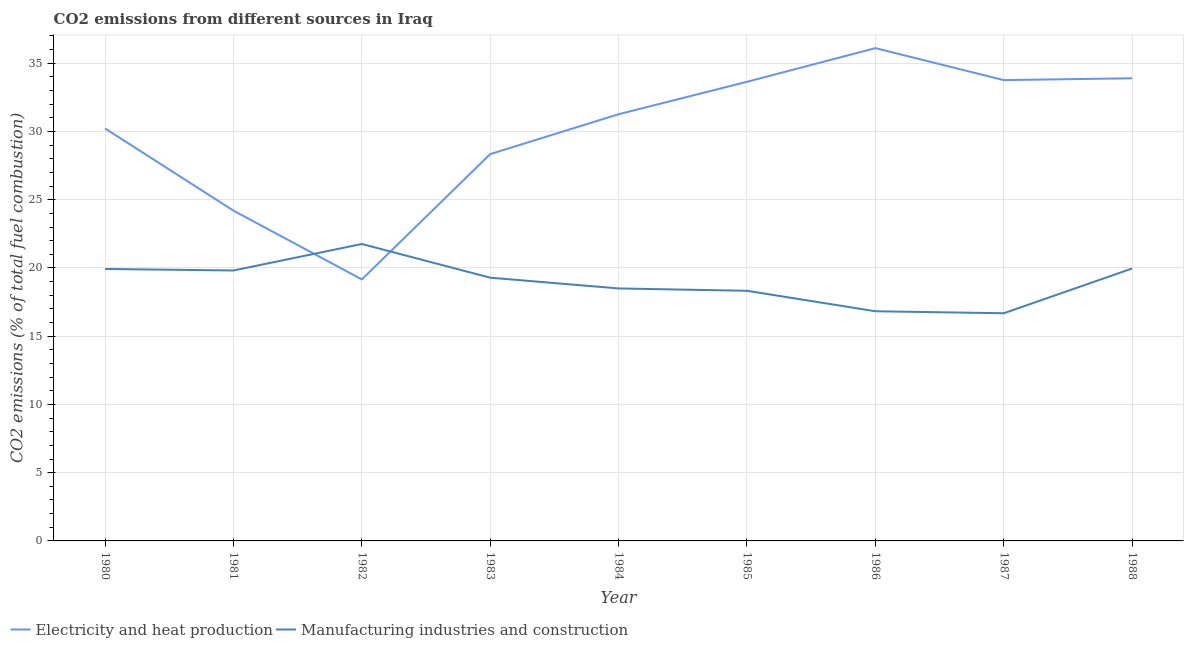What is the co2 emissions due to electricity and heat production in 1987?
Offer a very short reply. 33.77. Across all years, what is the maximum co2 emissions due to electricity and heat production?
Provide a succinct answer. 36.11. Across all years, what is the minimum co2 emissions due to electricity and heat production?
Your response must be concise. 19.16. What is the total co2 emissions due to manufacturing industries in the graph?
Your answer should be very brief. 171.08. What is the difference between the co2 emissions due to manufacturing industries in 1980 and that in 1986?
Provide a short and direct response. 3.1. What is the difference between the co2 emissions due to manufacturing industries in 1988 and the co2 emissions due to electricity and heat production in 1983?
Provide a succinct answer. -8.38. What is the average co2 emissions due to electricity and heat production per year?
Provide a short and direct response. 30.07. In the year 1988, what is the difference between the co2 emissions due to manufacturing industries and co2 emissions due to electricity and heat production?
Offer a very short reply. -13.94. In how many years, is the co2 emissions due to electricity and heat production greater than 2 %?
Provide a short and direct response. 9. What is the ratio of the co2 emissions due to manufacturing industries in 1981 to that in 1983?
Your answer should be compact. 1.03. Is the co2 emissions due to electricity and heat production in 1982 less than that in 1988?
Your answer should be compact. Yes. Is the difference between the co2 emissions due to electricity and heat production in 1980 and 1982 greater than the difference between the co2 emissions due to manufacturing industries in 1980 and 1982?
Provide a short and direct response. Yes. What is the difference between the highest and the second highest co2 emissions due to manufacturing industries?
Keep it short and to the point. 1.8. What is the difference between the highest and the lowest co2 emissions due to electricity and heat production?
Ensure brevity in your answer.  16.95. Does the co2 emissions due to electricity and heat production monotonically increase over the years?
Offer a terse response. No. Is the co2 emissions due to manufacturing industries strictly greater than the co2 emissions due to electricity and heat production over the years?
Keep it short and to the point. No. Is the co2 emissions due to electricity and heat production strictly less than the co2 emissions due to manufacturing industries over the years?
Keep it short and to the point. No. What is the difference between two consecutive major ticks on the Y-axis?
Make the answer very short. 5. Are the values on the major ticks of Y-axis written in scientific E-notation?
Your response must be concise. No. Does the graph contain any zero values?
Keep it short and to the point. No. Does the graph contain grids?
Your answer should be compact. Yes. How are the legend labels stacked?
Ensure brevity in your answer.  Horizontal. What is the title of the graph?
Your answer should be compact. CO2 emissions from different sources in Iraq. What is the label or title of the X-axis?
Keep it short and to the point. Year. What is the label or title of the Y-axis?
Your answer should be very brief. CO2 emissions (% of total fuel combustion). What is the CO2 emissions (% of total fuel combustion) in Electricity and heat production in 1980?
Offer a very short reply. 30.22. What is the CO2 emissions (% of total fuel combustion) in Manufacturing industries and construction in 1980?
Provide a succinct answer. 19.93. What is the CO2 emissions (% of total fuel combustion) in Electricity and heat production in 1981?
Your response must be concise. 24.2. What is the CO2 emissions (% of total fuel combustion) of Manufacturing industries and construction in 1981?
Give a very brief answer. 19.82. What is the CO2 emissions (% of total fuel combustion) of Electricity and heat production in 1982?
Your response must be concise. 19.16. What is the CO2 emissions (% of total fuel combustion) of Manufacturing industries and construction in 1982?
Offer a terse response. 21.76. What is the CO2 emissions (% of total fuel combustion) in Electricity and heat production in 1983?
Offer a very short reply. 28.34. What is the CO2 emissions (% of total fuel combustion) in Manufacturing industries and construction in 1983?
Ensure brevity in your answer.  19.29. What is the CO2 emissions (% of total fuel combustion) in Electricity and heat production in 1984?
Offer a very short reply. 31.26. What is the CO2 emissions (% of total fuel combustion) in Electricity and heat production in 1985?
Offer a terse response. 33.64. What is the CO2 emissions (% of total fuel combustion) in Manufacturing industries and construction in 1985?
Your response must be concise. 18.33. What is the CO2 emissions (% of total fuel combustion) of Electricity and heat production in 1986?
Ensure brevity in your answer.  36.11. What is the CO2 emissions (% of total fuel combustion) in Manufacturing industries and construction in 1986?
Provide a short and direct response. 16.83. What is the CO2 emissions (% of total fuel combustion) in Electricity and heat production in 1987?
Your answer should be very brief. 33.77. What is the CO2 emissions (% of total fuel combustion) in Manufacturing industries and construction in 1987?
Offer a very short reply. 16.68. What is the CO2 emissions (% of total fuel combustion) in Electricity and heat production in 1988?
Give a very brief answer. 33.9. What is the CO2 emissions (% of total fuel combustion) in Manufacturing industries and construction in 1988?
Keep it short and to the point. 19.96. Across all years, what is the maximum CO2 emissions (% of total fuel combustion) of Electricity and heat production?
Offer a very short reply. 36.11. Across all years, what is the maximum CO2 emissions (% of total fuel combustion) in Manufacturing industries and construction?
Make the answer very short. 21.76. Across all years, what is the minimum CO2 emissions (% of total fuel combustion) of Electricity and heat production?
Offer a terse response. 19.16. Across all years, what is the minimum CO2 emissions (% of total fuel combustion) in Manufacturing industries and construction?
Your response must be concise. 16.68. What is the total CO2 emissions (% of total fuel combustion) of Electricity and heat production in the graph?
Make the answer very short. 270.6. What is the total CO2 emissions (% of total fuel combustion) in Manufacturing industries and construction in the graph?
Provide a succinct answer. 171.08. What is the difference between the CO2 emissions (% of total fuel combustion) of Electricity and heat production in 1980 and that in 1981?
Your answer should be very brief. 6.02. What is the difference between the CO2 emissions (% of total fuel combustion) in Manufacturing industries and construction in 1980 and that in 1981?
Your answer should be very brief. 0.11. What is the difference between the CO2 emissions (% of total fuel combustion) in Electricity and heat production in 1980 and that in 1982?
Provide a succinct answer. 11.06. What is the difference between the CO2 emissions (% of total fuel combustion) of Manufacturing industries and construction in 1980 and that in 1982?
Provide a short and direct response. -1.83. What is the difference between the CO2 emissions (% of total fuel combustion) of Electricity and heat production in 1980 and that in 1983?
Ensure brevity in your answer.  1.88. What is the difference between the CO2 emissions (% of total fuel combustion) in Manufacturing industries and construction in 1980 and that in 1983?
Provide a short and direct response. 0.64. What is the difference between the CO2 emissions (% of total fuel combustion) of Electricity and heat production in 1980 and that in 1984?
Your answer should be very brief. -1.04. What is the difference between the CO2 emissions (% of total fuel combustion) of Manufacturing industries and construction in 1980 and that in 1984?
Your answer should be very brief. 1.43. What is the difference between the CO2 emissions (% of total fuel combustion) in Electricity and heat production in 1980 and that in 1985?
Keep it short and to the point. -3.42. What is the difference between the CO2 emissions (% of total fuel combustion) in Manufacturing industries and construction in 1980 and that in 1985?
Offer a very short reply. 1.6. What is the difference between the CO2 emissions (% of total fuel combustion) of Electricity and heat production in 1980 and that in 1986?
Your answer should be very brief. -5.88. What is the difference between the CO2 emissions (% of total fuel combustion) of Manufacturing industries and construction in 1980 and that in 1986?
Give a very brief answer. 3.1. What is the difference between the CO2 emissions (% of total fuel combustion) in Electricity and heat production in 1980 and that in 1987?
Provide a succinct answer. -3.54. What is the difference between the CO2 emissions (% of total fuel combustion) in Manufacturing industries and construction in 1980 and that in 1987?
Your answer should be very brief. 3.24. What is the difference between the CO2 emissions (% of total fuel combustion) in Electricity and heat production in 1980 and that in 1988?
Provide a short and direct response. -3.68. What is the difference between the CO2 emissions (% of total fuel combustion) of Manufacturing industries and construction in 1980 and that in 1988?
Make the answer very short. -0.04. What is the difference between the CO2 emissions (% of total fuel combustion) of Electricity and heat production in 1981 and that in 1982?
Provide a short and direct response. 5.04. What is the difference between the CO2 emissions (% of total fuel combustion) of Manufacturing industries and construction in 1981 and that in 1982?
Your answer should be very brief. -1.94. What is the difference between the CO2 emissions (% of total fuel combustion) in Electricity and heat production in 1981 and that in 1983?
Offer a very short reply. -4.14. What is the difference between the CO2 emissions (% of total fuel combustion) in Manufacturing industries and construction in 1981 and that in 1983?
Ensure brevity in your answer.  0.53. What is the difference between the CO2 emissions (% of total fuel combustion) in Electricity and heat production in 1981 and that in 1984?
Your answer should be very brief. -7.06. What is the difference between the CO2 emissions (% of total fuel combustion) in Manufacturing industries and construction in 1981 and that in 1984?
Your answer should be compact. 1.32. What is the difference between the CO2 emissions (% of total fuel combustion) of Electricity and heat production in 1981 and that in 1985?
Ensure brevity in your answer.  -9.44. What is the difference between the CO2 emissions (% of total fuel combustion) of Manufacturing industries and construction in 1981 and that in 1985?
Provide a short and direct response. 1.49. What is the difference between the CO2 emissions (% of total fuel combustion) of Electricity and heat production in 1981 and that in 1986?
Your answer should be very brief. -11.91. What is the difference between the CO2 emissions (% of total fuel combustion) in Manufacturing industries and construction in 1981 and that in 1986?
Keep it short and to the point. 2.99. What is the difference between the CO2 emissions (% of total fuel combustion) of Electricity and heat production in 1981 and that in 1987?
Provide a succinct answer. -9.56. What is the difference between the CO2 emissions (% of total fuel combustion) in Manufacturing industries and construction in 1981 and that in 1987?
Keep it short and to the point. 3.13. What is the difference between the CO2 emissions (% of total fuel combustion) in Electricity and heat production in 1981 and that in 1988?
Your answer should be very brief. -9.7. What is the difference between the CO2 emissions (% of total fuel combustion) of Manufacturing industries and construction in 1981 and that in 1988?
Your response must be concise. -0.15. What is the difference between the CO2 emissions (% of total fuel combustion) of Electricity and heat production in 1982 and that in 1983?
Offer a very short reply. -9.18. What is the difference between the CO2 emissions (% of total fuel combustion) in Manufacturing industries and construction in 1982 and that in 1983?
Keep it short and to the point. 2.47. What is the difference between the CO2 emissions (% of total fuel combustion) of Electricity and heat production in 1982 and that in 1984?
Your answer should be compact. -12.1. What is the difference between the CO2 emissions (% of total fuel combustion) of Manufacturing industries and construction in 1982 and that in 1984?
Provide a succinct answer. 3.26. What is the difference between the CO2 emissions (% of total fuel combustion) of Electricity and heat production in 1982 and that in 1985?
Your response must be concise. -14.48. What is the difference between the CO2 emissions (% of total fuel combustion) in Manufacturing industries and construction in 1982 and that in 1985?
Your response must be concise. 3.43. What is the difference between the CO2 emissions (% of total fuel combustion) in Electricity and heat production in 1982 and that in 1986?
Your answer should be very brief. -16.95. What is the difference between the CO2 emissions (% of total fuel combustion) of Manufacturing industries and construction in 1982 and that in 1986?
Give a very brief answer. 4.93. What is the difference between the CO2 emissions (% of total fuel combustion) in Electricity and heat production in 1982 and that in 1987?
Your answer should be compact. -14.6. What is the difference between the CO2 emissions (% of total fuel combustion) of Manufacturing industries and construction in 1982 and that in 1987?
Offer a very short reply. 5.07. What is the difference between the CO2 emissions (% of total fuel combustion) in Electricity and heat production in 1982 and that in 1988?
Offer a terse response. -14.74. What is the difference between the CO2 emissions (% of total fuel combustion) in Manufacturing industries and construction in 1982 and that in 1988?
Your answer should be compact. 1.8. What is the difference between the CO2 emissions (% of total fuel combustion) of Electricity and heat production in 1983 and that in 1984?
Make the answer very short. -2.92. What is the difference between the CO2 emissions (% of total fuel combustion) in Manufacturing industries and construction in 1983 and that in 1984?
Make the answer very short. 0.79. What is the difference between the CO2 emissions (% of total fuel combustion) of Electricity and heat production in 1983 and that in 1985?
Provide a succinct answer. -5.3. What is the difference between the CO2 emissions (% of total fuel combustion) in Manufacturing industries and construction in 1983 and that in 1985?
Ensure brevity in your answer.  0.96. What is the difference between the CO2 emissions (% of total fuel combustion) of Electricity and heat production in 1983 and that in 1986?
Make the answer very short. -7.76. What is the difference between the CO2 emissions (% of total fuel combustion) of Manufacturing industries and construction in 1983 and that in 1986?
Your answer should be very brief. 2.46. What is the difference between the CO2 emissions (% of total fuel combustion) of Electricity and heat production in 1983 and that in 1987?
Your response must be concise. -5.42. What is the difference between the CO2 emissions (% of total fuel combustion) in Manufacturing industries and construction in 1983 and that in 1987?
Give a very brief answer. 2.61. What is the difference between the CO2 emissions (% of total fuel combustion) of Electricity and heat production in 1983 and that in 1988?
Keep it short and to the point. -5.56. What is the difference between the CO2 emissions (% of total fuel combustion) in Manufacturing industries and construction in 1983 and that in 1988?
Your response must be concise. -0.67. What is the difference between the CO2 emissions (% of total fuel combustion) in Electricity and heat production in 1984 and that in 1985?
Make the answer very short. -2.38. What is the difference between the CO2 emissions (% of total fuel combustion) of Manufacturing industries and construction in 1984 and that in 1985?
Your answer should be compact. 0.17. What is the difference between the CO2 emissions (% of total fuel combustion) of Electricity and heat production in 1984 and that in 1986?
Provide a succinct answer. -4.84. What is the difference between the CO2 emissions (% of total fuel combustion) of Manufacturing industries and construction in 1984 and that in 1986?
Your answer should be compact. 1.67. What is the difference between the CO2 emissions (% of total fuel combustion) in Electricity and heat production in 1984 and that in 1987?
Your answer should be very brief. -2.5. What is the difference between the CO2 emissions (% of total fuel combustion) of Manufacturing industries and construction in 1984 and that in 1987?
Your answer should be compact. 1.82. What is the difference between the CO2 emissions (% of total fuel combustion) in Electricity and heat production in 1984 and that in 1988?
Offer a terse response. -2.63. What is the difference between the CO2 emissions (% of total fuel combustion) of Manufacturing industries and construction in 1984 and that in 1988?
Offer a very short reply. -1.46. What is the difference between the CO2 emissions (% of total fuel combustion) in Electricity and heat production in 1985 and that in 1986?
Give a very brief answer. -2.47. What is the difference between the CO2 emissions (% of total fuel combustion) in Manufacturing industries and construction in 1985 and that in 1986?
Provide a short and direct response. 1.5. What is the difference between the CO2 emissions (% of total fuel combustion) of Electricity and heat production in 1985 and that in 1987?
Ensure brevity in your answer.  -0.12. What is the difference between the CO2 emissions (% of total fuel combustion) in Manufacturing industries and construction in 1985 and that in 1987?
Keep it short and to the point. 1.65. What is the difference between the CO2 emissions (% of total fuel combustion) of Electricity and heat production in 1985 and that in 1988?
Your answer should be very brief. -0.26. What is the difference between the CO2 emissions (% of total fuel combustion) in Manufacturing industries and construction in 1985 and that in 1988?
Provide a short and direct response. -1.63. What is the difference between the CO2 emissions (% of total fuel combustion) in Electricity and heat production in 1986 and that in 1987?
Make the answer very short. 2.34. What is the difference between the CO2 emissions (% of total fuel combustion) of Manufacturing industries and construction in 1986 and that in 1987?
Your answer should be compact. 0.15. What is the difference between the CO2 emissions (% of total fuel combustion) of Electricity and heat production in 1986 and that in 1988?
Provide a short and direct response. 2.21. What is the difference between the CO2 emissions (% of total fuel combustion) in Manufacturing industries and construction in 1986 and that in 1988?
Your response must be concise. -3.13. What is the difference between the CO2 emissions (% of total fuel combustion) in Electricity and heat production in 1987 and that in 1988?
Your answer should be compact. -0.13. What is the difference between the CO2 emissions (% of total fuel combustion) in Manufacturing industries and construction in 1987 and that in 1988?
Make the answer very short. -3.28. What is the difference between the CO2 emissions (% of total fuel combustion) in Electricity and heat production in 1980 and the CO2 emissions (% of total fuel combustion) in Manufacturing industries and construction in 1981?
Ensure brevity in your answer.  10.41. What is the difference between the CO2 emissions (% of total fuel combustion) of Electricity and heat production in 1980 and the CO2 emissions (% of total fuel combustion) of Manufacturing industries and construction in 1982?
Ensure brevity in your answer.  8.47. What is the difference between the CO2 emissions (% of total fuel combustion) in Electricity and heat production in 1980 and the CO2 emissions (% of total fuel combustion) in Manufacturing industries and construction in 1983?
Provide a short and direct response. 10.93. What is the difference between the CO2 emissions (% of total fuel combustion) of Electricity and heat production in 1980 and the CO2 emissions (% of total fuel combustion) of Manufacturing industries and construction in 1984?
Keep it short and to the point. 11.72. What is the difference between the CO2 emissions (% of total fuel combustion) in Electricity and heat production in 1980 and the CO2 emissions (% of total fuel combustion) in Manufacturing industries and construction in 1985?
Your answer should be compact. 11.89. What is the difference between the CO2 emissions (% of total fuel combustion) in Electricity and heat production in 1980 and the CO2 emissions (% of total fuel combustion) in Manufacturing industries and construction in 1986?
Your answer should be compact. 13.39. What is the difference between the CO2 emissions (% of total fuel combustion) of Electricity and heat production in 1980 and the CO2 emissions (% of total fuel combustion) of Manufacturing industries and construction in 1987?
Offer a terse response. 13.54. What is the difference between the CO2 emissions (% of total fuel combustion) of Electricity and heat production in 1980 and the CO2 emissions (% of total fuel combustion) of Manufacturing industries and construction in 1988?
Your answer should be very brief. 10.26. What is the difference between the CO2 emissions (% of total fuel combustion) of Electricity and heat production in 1981 and the CO2 emissions (% of total fuel combustion) of Manufacturing industries and construction in 1982?
Offer a terse response. 2.45. What is the difference between the CO2 emissions (% of total fuel combustion) in Electricity and heat production in 1981 and the CO2 emissions (% of total fuel combustion) in Manufacturing industries and construction in 1983?
Offer a very short reply. 4.91. What is the difference between the CO2 emissions (% of total fuel combustion) of Electricity and heat production in 1981 and the CO2 emissions (% of total fuel combustion) of Manufacturing industries and construction in 1984?
Ensure brevity in your answer.  5.7. What is the difference between the CO2 emissions (% of total fuel combustion) in Electricity and heat production in 1981 and the CO2 emissions (% of total fuel combustion) in Manufacturing industries and construction in 1985?
Offer a very short reply. 5.87. What is the difference between the CO2 emissions (% of total fuel combustion) of Electricity and heat production in 1981 and the CO2 emissions (% of total fuel combustion) of Manufacturing industries and construction in 1986?
Give a very brief answer. 7.37. What is the difference between the CO2 emissions (% of total fuel combustion) of Electricity and heat production in 1981 and the CO2 emissions (% of total fuel combustion) of Manufacturing industries and construction in 1987?
Your response must be concise. 7.52. What is the difference between the CO2 emissions (% of total fuel combustion) of Electricity and heat production in 1981 and the CO2 emissions (% of total fuel combustion) of Manufacturing industries and construction in 1988?
Your answer should be very brief. 4.24. What is the difference between the CO2 emissions (% of total fuel combustion) of Electricity and heat production in 1982 and the CO2 emissions (% of total fuel combustion) of Manufacturing industries and construction in 1983?
Give a very brief answer. -0.13. What is the difference between the CO2 emissions (% of total fuel combustion) in Electricity and heat production in 1982 and the CO2 emissions (% of total fuel combustion) in Manufacturing industries and construction in 1984?
Your response must be concise. 0.66. What is the difference between the CO2 emissions (% of total fuel combustion) in Electricity and heat production in 1982 and the CO2 emissions (% of total fuel combustion) in Manufacturing industries and construction in 1985?
Your answer should be very brief. 0.83. What is the difference between the CO2 emissions (% of total fuel combustion) of Electricity and heat production in 1982 and the CO2 emissions (% of total fuel combustion) of Manufacturing industries and construction in 1986?
Provide a short and direct response. 2.33. What is the difference between the CO2 emissions (% of total fuel combustion) of Electricity and heat production in 1982 and the CO2 emissions (% of total fuel combustion) of Manufacturing industries and construction in 1987?
Keep it short and to the point. 2.48. What is the difference between the CO2 emissions (% of total fuel combustion) of Electricity and heat production in 1983 and the CO2 emissions (% of total fuel combustion) of Manufacturing industries and construction in 1984?
Offer a very short reply. 9.84. What is the difference between the CO2 emissions (% of total fuel combustion) of Electricity and heat production in 1983 and the CO2 emissions (% of total fuel combustion) of Manufacturing industries and construction in 1985?
Make the answer very short. 10.02. What is the difference between the CO2 emissions (% of total fuel combustion) of Electricity and heat production in 1983 and the CO2 emissions (% of total fuel combustion) of Manufacturing industries and construction in 1986?
Make the answer very short. 11.51. What is the difference between the CO2 emissions (% of total fuel combustion) of Electricity and heat production in 1983 and the CO2 emissions (% of total fuel combustion) of Manufacturing industries and construction in 1987?
Provide a succinct answer. 11.66. What is the difference between the CO2 emissions (% of total fuel combustion) of Electricity and heat production in 1983 and the CO2 emissions (% of total fuel combustion) of Manufacturing industries and construction in 1988?
Offer a very short reply. 8.38. What is the difference between the CO2 emissions (% of total fuel combustion) in Electricity and heat production in 1984 and the CO2 emissions (% of total fuel combustion) in Manufacturing industries and construction in 1985?
Provide a short and direct response. 12.94. What is the difference between the CO2 emissions (% of total fuel combustion) in Electricity and heat production in 1984 and the CO2 emissions (% of total fuel combustion) in Manufacturing industries and construction in 1986?
Offer a terse response. 14.44. What is the difference between the CO2 emissions (% of total fuel combustion) of Electricity and heat production in 1984 and the CO2 emissions (% of total fuel combustion) of Manufacturing industries and construction in 1987?
Ensure brevity in your answer.  14.58. What is the difference between the CO2 emissions (% of total fuel combustion) of Electricity and heat production in 1984 and the CO2 emissions (% of total fuel combustion) of Manufacturing industries and construction in 1988?
Ensure brevity in your answer.  11.3. What is the difference between the CO2 emissions (% of total fuel combustion) of Electricity and heat production in 1985 and the CO2 emissions (% of total fuel combustion) of Manufacturing industries and construction in 1986?
Offer a terse response. 16.81. What is the difference between the CO2 emissions (% of total fuel combustion) in Electricity and heat production in 1985 and the CO2 emissions (% of total fuel combustion) in Manufacturing industries and construction in 1987?
Your answer should be compact. 16.96. What is the difference between the CO2 emissions (% of total fuel combustion) of Electricity and heat production in 1985 and the CO2 emissions (% of total fuel combustion) of Manufacturing industries and construction in 1988?
Your response must be concise. 13.68. What is the difference between the CO2 emissions (% of total fuel combustion) in Electricity and heat production in 1986 and the CO2 emissions (% of total fuel combustion) in Manufacturing industries and construction in 1987?
Make the answer very short. 19.43. What is the difference between the CO2 emissions (% of total fuel combustion) of Electricity and heat production in 1986 and the CO2 emissions (% of total fuel combustion) of Manufacturing industries and construction in 1988?
Ensure brevity in your answer.  16.15. What is the difference between the CO2 emissions (% of total fuel combustion) in Electricity and heat production in 1987 and the CO2 emissions (% of total fuel combustion) in Manufacturing industries and construction in 1988?
Your answer should be compact. 13.8. What is the average CO2 emissions (% of total fuel combustion) in Electricity and heat production per year?
Provide a succinct answer. 30.07. What is the average CO2 emissions (% of total fuel combustion) of Manufacturing industries and construction per year?
Your answer should be very brief. 19.01. In the year 1980, what is the difference between the CO2 emissions (% of total fuel combustion) of Electricity and heat production and CO2 emissions (% of total fuel combustion) of Manufacturing industries and construction?
Your response must be concise. 10.3. In the year 1981, what is the difference between the CO2 emissions (% of total fuel combustion) in Electricity and heat production and CO2 emissions (% of total fuel combustion) in Manufacturing industries and construction?
Give a very brief answer. 4.39. In the year 1982, what is the difference between the CO2 emissions (% of total fuel combustion) of Electricity and heat production and CO2 emissions (% of total fuel combustion) of Manufacturing industries and construction?
Provide a short and direct response. -2.6. In the year 1983, what is the difference between the CO2 emissions (% of total fuel combustion) in Electricity and heat production and CO2 emissions (% of total fuel combustion) in Manufacturing industries and construction?
Provide a succinct answer. 9.06. In the year 1984, what is the difference between the CO2 emissions (% of total fuel combustion) in Electricity and heat production and CO2 emissions (% of total fuel combustion) in Manufacturing industries and construction?
Keep it short and to the point. 12.76. In the year 1985, what is the difference between the CO2 emissions (% of total fuel combustion) in Electricity and heat production and CO2 emissions (% of total fuel combustion) in Manufacturing industries and construction?
Keep it short and to the point. 15.31. In the year 1986, what is the difference between the CO2 emissions (% of total fuel combustion) in Electricity and heat production and CO2 emissions (% of total fuel combustion) in Manufacturing industries and construction?
Keep it short and to the point. 19.28. In the year 1987, what is the difference between the CO2 emissions (% of total fuel combustion) of Electricity and heat production and CO2 emissions (% of total fuel combustion) of Manufacturing industries and construction?
Ensure brevity in your answer.  17.08. In the year 1988, what is the difference between the CO2 emissions (% of total fuel combustion) in Electricity and heat production and CO2 emissions (% of total fuel combustion) in Manufacturing industries and construction?
Provide a short and direct response. 13.94. What is the ratio of the CO2 emissions (% of total fuel combustion) in Electricity and heat production in 1980 to that in 1981?
Offer a very short reply. 1.25. What is the ratio of the CO2 emissions (% of total fuel combustion) of Manufacturing industries and construction in 1980 to that in 1981?
Provide a succinct answer. 1.01. What is the ratio of the CO2 emissions (% of total fuel combustion) in Electricity and heat production in 1980 to that in 1982?
Ensure brevity in your answer.  1.58. What is the ratio of the CO2 emissions (% of total fuel combustion) in Manufacturing industries and construction in 1980 to that in 1982?
Make the answer very short. 0.92. What is the ratio of the CO2 emissions (% of total fuel combustion) in Electricity and heat production in 1980 to that in 1983?
Your answer should be very brief. 1.07. What is the ratio of the CO2 emissions (% of total fuel combustion) of Manufacturing industries and construction in 1980 to that in 1983?
Provide a succinct answer. 1.03. What is the ratio of the CO2 emissions (% of total fuel combustion) of Electricity and heat production in 1980 to that in 1984?
Ensure brevity in your answer.  0.97. What is the ratio of the CO2 emissions (% of total fuel combustion) in Manufacturing industries and construction in 1980 to that in 1984?
Provide a succinct answer. 1.08. What is the ratio of the CO2 emissions (% of total fuel combustion) of Electricity and heat production in 1980 to that in 1985?
Give a very brief answer. 0.9. What is the ratio of the CO2 emissions (% of total fuel combustion) of Manufacturing industries and construction in 1980 to that in 1985?
Provide a succinct answer. 1.09. What is the ratio of the CO2 emissions (% of total fuel combustion) of Electricity and heat production in 1980 to that in 1986?
Ensure brevity in your answer.  0.84. What is the ratio of the CO2 emissions (% of total fuel combustion) of Manufacturing industries and construction in 1980 to that in 1986?
Your answer should be compact. 1.18. What is the ratio of the CO2 emissions (% of total fuel combustion) in Electricity and heat production in 1980 to that in 1987?
Your answer should be compact. 0.9. What is the ratio of the CO2 emissions (% of total fuel combustion) in Manufacturing industries and construction in 1980 to that in 1987?
Offer a very short reply. 1.19. What is the ratio of the CO2 emissions (% of total fuel combustion) of Electricity and heat production in 1980 to that in 1988?
Offer a terse response. 0.89. What is the ratio of the CO2 emissions (% of total fuel combustion) of Manufacturing industries and construction in 1980 to that in 1988?
Provide a succinct answer. 1. What is the ratio of the CO2 emissions (% of total fuel combustion) in Electricity and heat production in 1981 to that in 1982?
Provide a short and direct response. 1.26. What is the ratio of the CO2 emissions (% of total fuel combustion) of Manufacturing industries and construction in 1981 to that in 1982?
Your answer should be compact. 0.91. What is the ratio of the CO2 emissions (% of total fuel combustion) of Electricity and heat production in 1981 to that in 1983?
Offer a very short reply. 0.85. What is the ratio of the CO2 emissions (% of total fuel combustion) of Manufacturing industries and construction in 1981 to that in 1983?
Provide a short and direct response. 1.03. What is the ratio of the CO2 emissions (% of total fuel combustion) of Electricity and heat production in 1981 to that in 1984?
Your answer should be compact. 0.77. What is the ratio of the CO2 emissions (% of total fuel combustion) of Manufacturing industries and construction in 1981 to that in 1984?
Your answer should be very brief. 1.07. What is the ratio of the CO2 emissions (% of total fuel combustion) in Electricity and heat production in 1981 to that in 1985?
Provide a short and direct response. 0.72. What is the ratio of the CO2 emissions (% of total fuel combustion) in Manufacturing industries and construction in 1981 to that in 1985?
Your response must be concise. 1.08. What is the ratio of the CO2 emissions (% of total fuel combustion) in Electricity and heat production in 1981 to that in 1986?
Keep it short and to the point. 0.67. What is the ratio of the CO2 emissions (% of total fuel combustion) in Manufacturing industries and construction in 1981 to that in 1986?
Your answer should be compact. 1.18. What is the ratio of the CO2 emissions (% of total fuel combustion) in Electricity and heat production in 1981 to that in 1987?
Ensure brevity in your answer.  0.72. What is the ratio of the CO2 emissions (% of total fuel combustion) of Manufacturing industries and construction in 1981 to that in 1987?
Keep it short and to the point. 1.19. What is the ratio of the CO2 emissions (% of total fuel combustion) in Electricity and heat production in 1981 to that in 1988?
Ensure brevity in your answer.  0.71. What is the ratio of the CO2 emissions (% of total fuel combustion) of Manufacturing industries and construction in 1981 to that in 1988?
Ensure brevity in your answer.  0.99. What is the ratio of the CO2 emissions (% of total fuel combustion) of Electricity and heat production in 1982 to that in 1983?
Provide a short and direct response. 0.68. What is the ratio of the CO2 emissions (% of total fuel combustion) of Manufacturing industries and construction in 1982 to that in 1983?
Your response must be concise. 1.13. What is the ratio of the CO2 emissions (% of total fuel combustion) of Electricity and heat production in 1982 to that in 1984?
Offer a very short reply. 0.61. What is the ratio of the CO2 emissions (% of total fuel combustion) of Manufacturing industries and construction in 1982 to that in 1984?
Offer a terse response. 1.18. What is the ratio of the CO2 emissions (% of total fuel combustion) in Electricity and heat production in 1982 to that in 1985?
Give a very brief answer. 0.57. What is the ratio of the CO2 emissions (% of total fuel combustion) of Manufacturing industries and construction in 1982 to that in 1985?
Give a very brief answer. 1.19. What is the ratio of the CO2 emissions (% of total fuel combustion) in Electricity and heat production in 1982 to that in 1986?
Keep it short and to the point. 0.53. What is the ratio of the CO2 emissions (% of total fuel combustion) in Manufacturing industries and construction in 1982 to that in 1986?
Provide a short and direct response. 1.29. What is the ratio of the CO2 emissions (% of total fuel combustion) in Electricity and heat production in 1982 to that in 1987?
Offer a very short reply. 0.57. What is the ratio of the CO2 emissions (% of total fuel combustion) in Manufacturing industries and construction in 1982 to that in 1987?
Your answer should be compact. 1.3. What is the ratio of the CO2 emissions (% of total fuel combustion) of Electricity and heat production in 1982 to that in 1988?
Ensure brevity in your answer.  0.57. What is the ratio of the CO2 emissions (% of total fuel combustion) of Manufacturing industries and construction in 1982 to that in 1988?
Provide a short and direct response. 1.09. What is the ratio of the CO2 emissions (% of total fuel combustion) in Electricity and heat production in 1983 to that in 1984?
Provide a succinct answer. 0.91. What is the ratio of the CO2 emissions (% of total fuel combustion) of Manufacturing industries and construction in 1983 to that in 1984?
Your answer should be compact. 1.04. What is the ratio of the CO2 emissions (% of total fuel combustion) in Electricity and heat production in 1983 to that in 1985?
Provide a succinct answer. 0.84. What is the ratio of the CO2 emissions (% of total fuel combustion) in Manufacturing industries and construction in 1983 to that in 1985?
Provide a succinct answer. 1.05. What is the ratio of the CO2 emissions (% of total fuel combustion) of Electricity and heat production in 1983 to that in 1986?
Provide a short and direct response. 0.79. What is the ratio of the CO2 emissions (% of total fuel combustion) of Manufacturing industries and construction in 1983 to that in 1986?
Offer a terse response. 1.15. What is the ratio of the CO2 emissions (% of total fuel combustion) of Electricity and heat production in 1983 to that in 1987?
Offer a terse response. 0.84. What is the ratio of the CO2 emissions (% of total fuel combustion) of Manufacturing industries and construction in 1983 to that in 1987?
Your answer should be very brief. 1.16. What is the ratio of the CO2 emissions (% of total fuel combustion) in Electricity and heat production in 1983 to that in 1988?
Provide a short and direct response. 0.84. What is the ratio of the CO2 emissions (% of total fuel combustion) of Manufacturing industries and construction in 1983 to that in 1988?
Keep it short and to the point. 0.97. What is the ratio of the CO2 emissions (% of total fuel combustion) of Electricity and heat production in 1984 to that in 1985?
Your answer should be compact. 0.93. What is the ratio of the CO2 emissions (% of total fuel combustion) of Manufacturing industries and construction in 1984 to that in 1985?
Provide a short and direct response. 1.01. What is the ratio of the CO2 emissions (% of total fuel combustion) in Electricity and heat production in 1984 to that in 1986?
Your answer should be compact. 0.87. What is the ratio of the CO2 emissions (% of total fuel combustion) of Manufacturing industries and construction in 1984 to that in 1986?
Offer a terse response. 1.1. What is the ratio of the CO2 emissions (% of total fuel combustion) in Electricity and heat production in 1984 to that in 1987?
Provide a succinct answer. 0.93. What is the ratio of the CO2 emissions (% of total fuel combustion) in Manufacturing industries and construction in 1984 to that in 1987?
Make the answer very short. 1.11. What is the ratio of the CO2 emissions (% of total fuel combustion) in Electricity and heat production in 1984 to that in 1988?
Your response must be concise. 0.92. What is the ratio of the CO2 emissions (% of total fuel combustion) of Manufacturing industries and construction in 1984 to that in 1988?
Your answer should be very brief. 0.93. What is the ratio of the CO2 emissions (% of total fuel combustion) of Electricity and heat production in 1985 to that in 1986?
Provide a short and direct response. 0.93. What is the ratio of the CO2 emissions (% of total fuel combustion) in Manufacturing industries and construction in 1985 to that in 1986?
Give a very brief answer. 1.09. What is the ratio of the CO2 emissions (% of total fuel combustion) of Manufacturing industries and construction in 1985 to that in 1987?
Your answer should be compact. 1.1. What is the ratio of the CO2 emissions (% of total fuel combustion) of Electricity and heat production in 1985 to that in 1988?
Make the answer very short. 0.99. What is the ratio of the CO2 emissions (% of total fuel combustion) of Manufacturing industries and construction in 1985 to that in 1988?
Your response must be concise. 0.92. What is the ratio of the CO2 emissions (% of total fuel combustion) in Electricity and heat production in 1986 to that in 1987?
Your answer should be very brief. 1.07. What is the ratio of the CO2 emissions (% of total fuel combustion) in Manufacturing industries and construction in 1986 to that in 1987?
Offer a terse response. 1.01. What is the ratio of the CO2 emissions (% of total fuel combustion) of Electricity and heat production in 1986 to that in 1988?
Your answer should be compact. 1.07. What is the ratio of the CO2 emissions (% of total fuel combustion) in Manufacturing industries and construction in 1986 to that in 1988?
Your answer should be very brief. 0.84. What is the ratio of the CO2 emissions (% of total fuel combustion) in Manufacturing industries and construction in 1987 to that in 1988?
Keep it short and to the point. 0.84. What is the difference between the highest and the second highest CO2 emissions (% of total fuel combustion) in Electricity and heat production?
Your answer should be very brief. 2.21. What is the difference between the highest and the second highest CO2 emissions (% of total fuel combustion) of Manufacturing industries and construction?
Your answer should be very brief. 1.8. What is the difference between the highest and the lowest CO2 emissions (% of total fuel combustion) of Electricity and heat production?
Provide a short and direct response. 16.95. What is the difference between the highest and the lowest CO2 emissions (% of total fuel combustion) in Manufacturing industries and construction?
Your response must be concise. 5.07. 